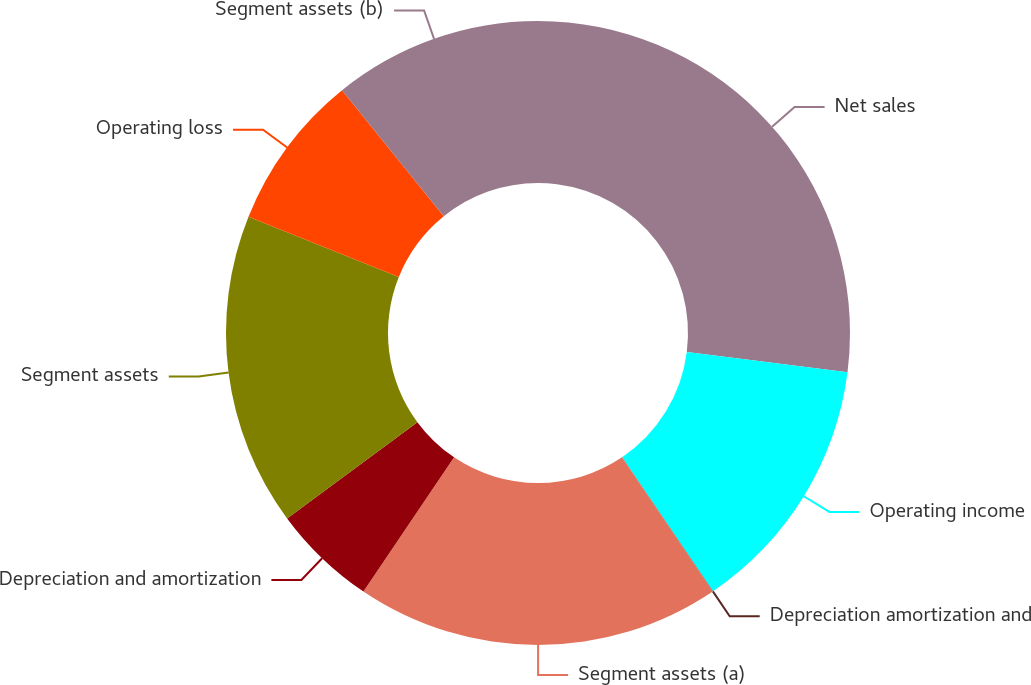Convert chart to OTSL. <chart><loc_0><loc_0><loc_500><loc_500><pie_chart><fcel>Net sales<fcel>Operating income<fcel>Depreciation amortization and<fcel>Segment assets (a)<fcel>Depreciation and amortization<fcel>Segment assets<fcel>Operating loss<fcel>Segment assets (b)<nl><fcel>27.01%<fcel>13.51%<fcel>0.02%<fcel>18.91%<fcel>5.42%<fcel>16.21%<fcel>8.11%<fcel>10.81%<nl></chart> 